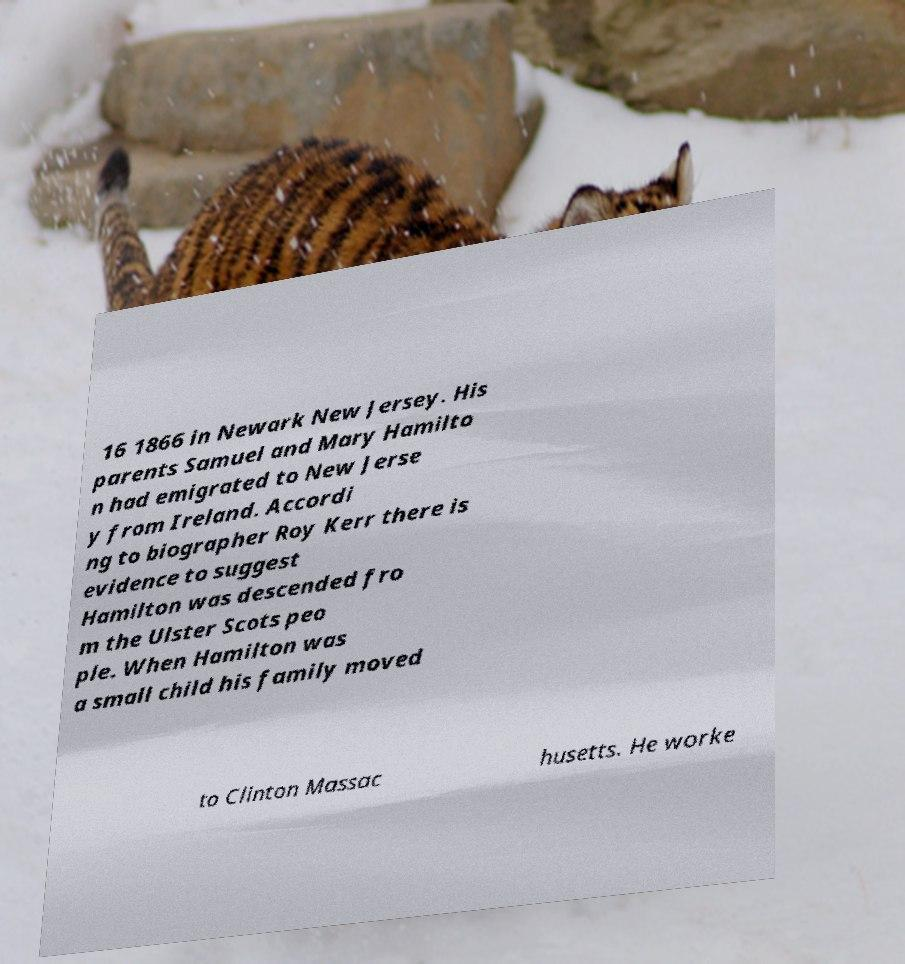I need the written content from this picture converted into text. Can you do that? 16 1866 in Newark New Jersey. His parents Samuel and Mary Hamilto n had emigrated to New Jerse y from Ireland. Accordi ng to biographer Roy Kerr there is evidence to suggest Hamilton was descended fro m the Ulster Scots peo ple. When Hamilton was a small child his family moved to Clinton Massac husetts. He worke 